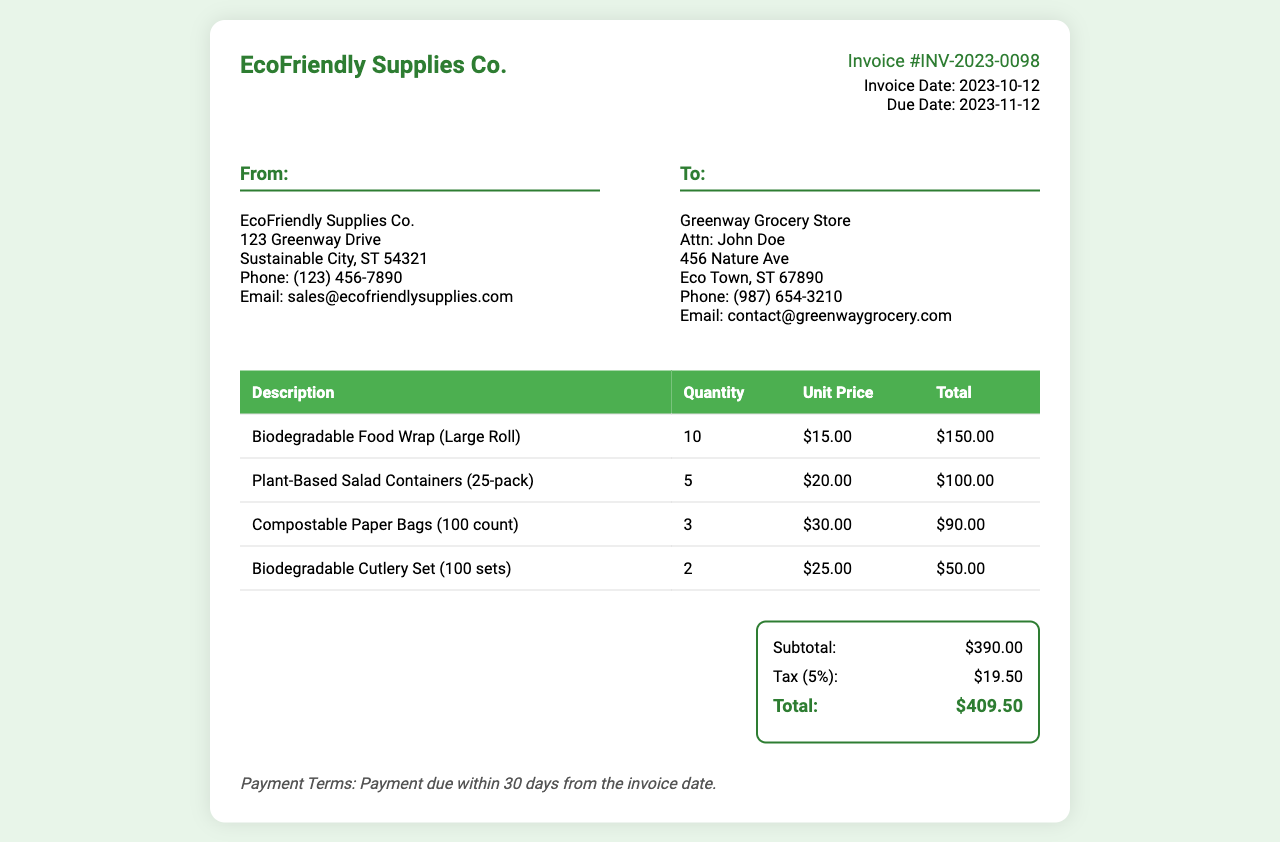What is the invoice number? The invoice number is clearly labeled in the document as a unique identifier for this invoice.
Answer: INV-2023-0098 What is the invoice date? The invoice date shows when the invoice was generated, located in the invoice details section.
Answer: 2023-10-12 What is the due date for payment? The due date indicates the deadline for payment, which can be found in the invoice details.
Answer: 2023-11-12 What is the subtotal amount? The subtotal is the total of the item prices before tax, located in the totals section of the invoice.
Answer: $390.00 What is the tax percentage applied? The tax percentage is stated in the totals section as part of the financial breakdown.
Answer: 5% How many biodegradable food wraps were purchased? The quantity of biodegradable food wraps specifies how many units were ordered, clearly shown in the item list.
Answer: 10 What is the total amount due? The total amount encompasses the subtotal plus tax, which is summarized in the totals section.
Answer: $409.50 Who is the supplier? The supplier is identified at the top of the document under the "From" section, indicating who issued the invoice.
Answer: EcoFriendly Supplies Co What type of payment terms are stated? The payment terms outline the conditions for payment, found at the bottom of the invoice.
Answer: Payment due within 30 days from the invoice date 